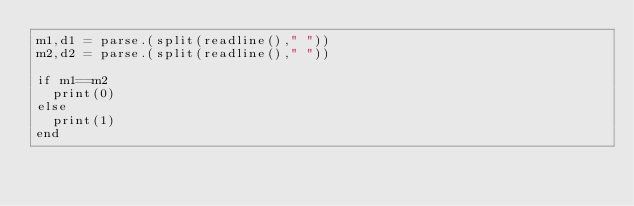Convert code to text. <code><loc_0><loc_0><loc_500><loc_500><_Julia_>m1,d1 = parse.(split(readline()," "))
m2,d2 = parse.(split(readline()," "))

if m1==m2
  print(0)
else
  print(1)
end</code> 